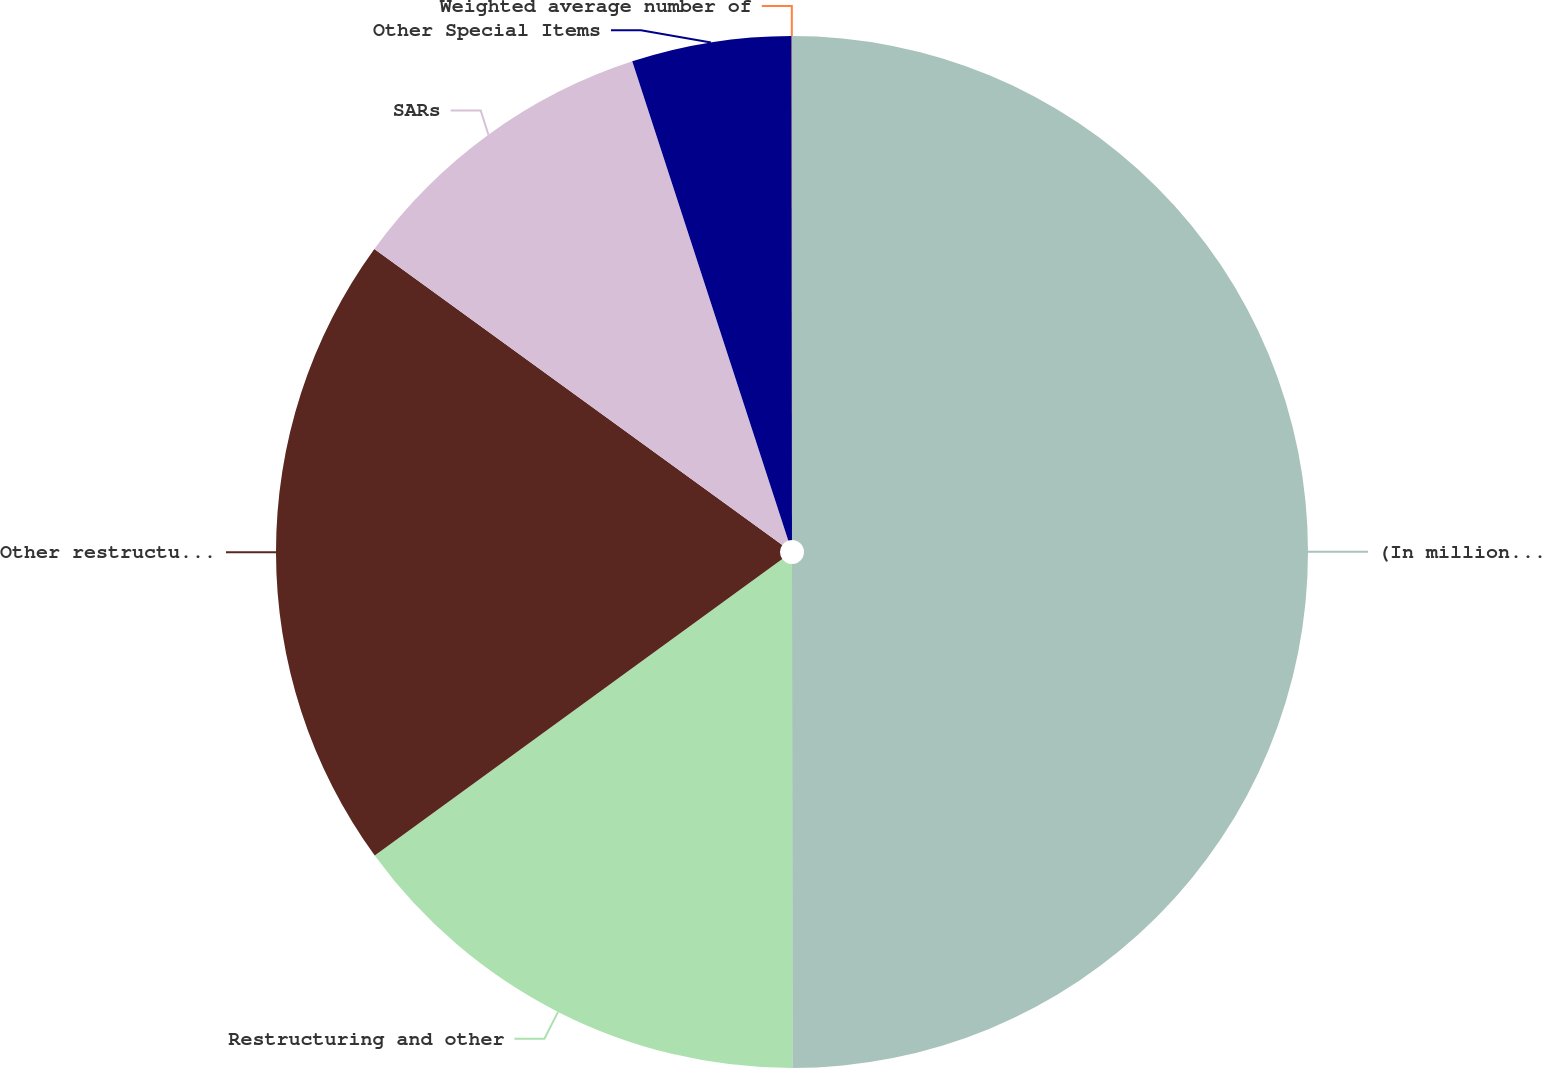Convert chart to OTSL. <chart><loc_0><loc_0><loc_500><loc_500><pie_chart><fcel>(In millions except per share<fcel>Restructuring and other<fcel>Other restructuring associated<fcel>SARs<fcel>Other Special Items<fcel>Weighted average number of<nl><fcel>49.99%<fcel>15.0%<fcel>20.0%<fcel>10.0%<fcel>5.0%<fcel>0.01%<nl></chart> 